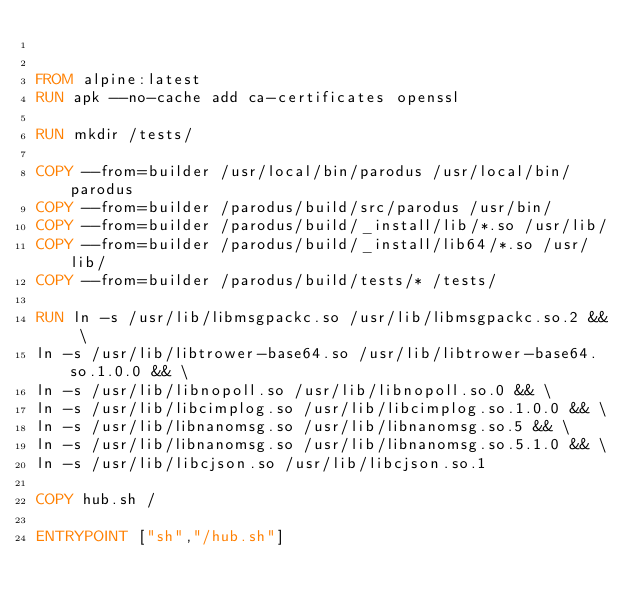Convert code to text. <code><loc_0><loc_0><loc_500><loc_500><_Dockerfile_>

FROM alpine:latest
RUN apk --no-cache add ca-certificates openssl

RUN mkdir /tests/

COPY --from=builder /usr/local/bin/parodus /usr/local/bin/parodus
COPY --from=builder /parodus/build/src/parodus /usr/bin/
COPY --from=builder /parodus/build/_install/lib/*.so /usr/lib/
COPY --from=builder /parodus/build/_install/lib64/*.so /usr/lib/
COPY --from=builder /parodus/build/tests/* /tests/

RUN ln -s /usr/lib/libmsgpackc.so /usr/lib/libmsgpackc.so.2 && \
ln -s /usr/lib/libtrower-base64.so /usr/lib/libtrower-base64.so.1.0.0 && \
ln -s /usr/lib/libnopoll.so /usr/lib/libnopoll.so.0 && \
ln -s /usr/lib/libcimplog.so /usr/lib/libcimplog.so.1.0.0 && \
ln -s /usr/lib/libnanomsg.so /usr/lib/libnanomsg.so.5 && \
ln -s /usr/lib/libnanomsg.so /usr/lib/libnanomsg.so.5.1.0 && \
ln -s /usr/lib/libcjson.so /usr/lib/libcjson.so.1

COPY hub.sh /

ENTRYPOINT ["sh","/hub.sh"]
</code> 